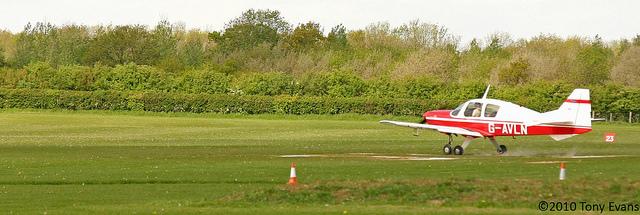How many traffic cones are visible?
Be succinct. 2. What color is the plane?
Quick response, please. White and red. What color is the bottom half of this airplane?
Concise answer only. Red. Is it clear out?
Answer briefly. Yes. What is the accent color on each of the wings?
Quick response, please. White. 